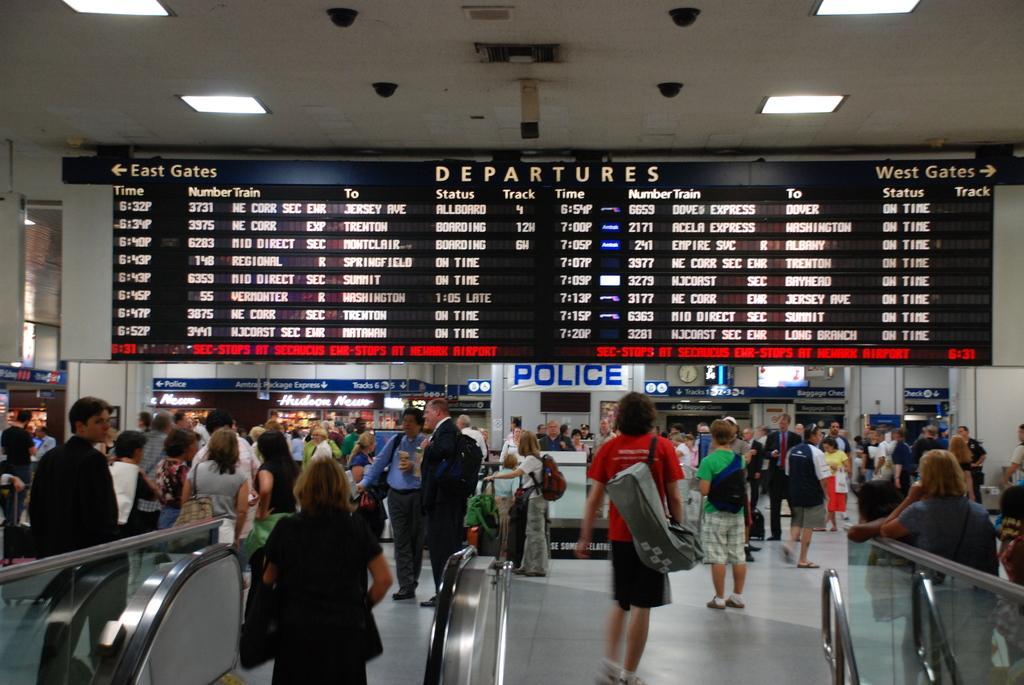Could you give a brief overview of what you see in this image? In this image, there are a few people. We can see the ground. We can also see some objects at the bottom. We can also see the glass fence. We can see the wall and some boards with text. There are a few display screens and some pillars. We can also see the roof with some lights and objects attached to it. 